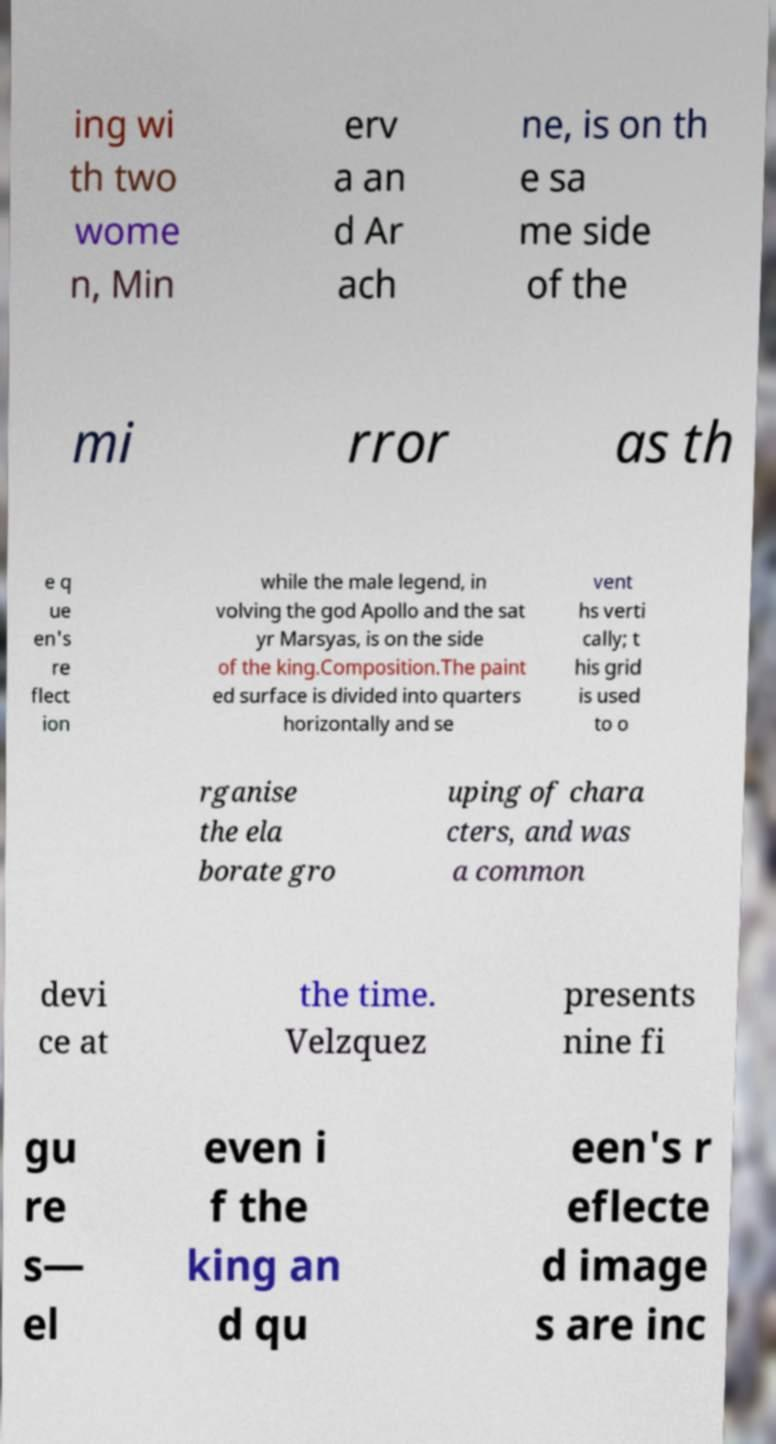Please read and relay the text visible in this image. What does it say? ing wi th two wome n, Min erv a an d Ar ach ne, is on th e sa me side of the mi rror as th e q ue en's re flect ion while the male legend, in volving the god Apollo and the sat yr Marsyas, is on the side of the king.Composition.The paint ed surface is divided into quarters horizontally and se vent hs verti cally; t his grid is used to o rganise the ela borate gro uping of chara cters, and was a common devi ce at the time. Velzquez presents nine fi gu re s— el even i f the king an d qu een's r eflecte d image s are inc 